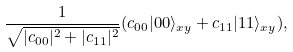Convert formula to latex. <formula><loc_0><loc_0><loc_500><loc_500>\frac { 1 } { \sqrt { | c _ { 0 0 } | ^ { 2 } + | c _ { 1 1 } | ^ { 2 } } } ( c _ { 0 0 } | 0 0 \rangle _ { x y } + c _ { 1 1 } | 1 1 \rangle _ { x y } ) ,</formula> 